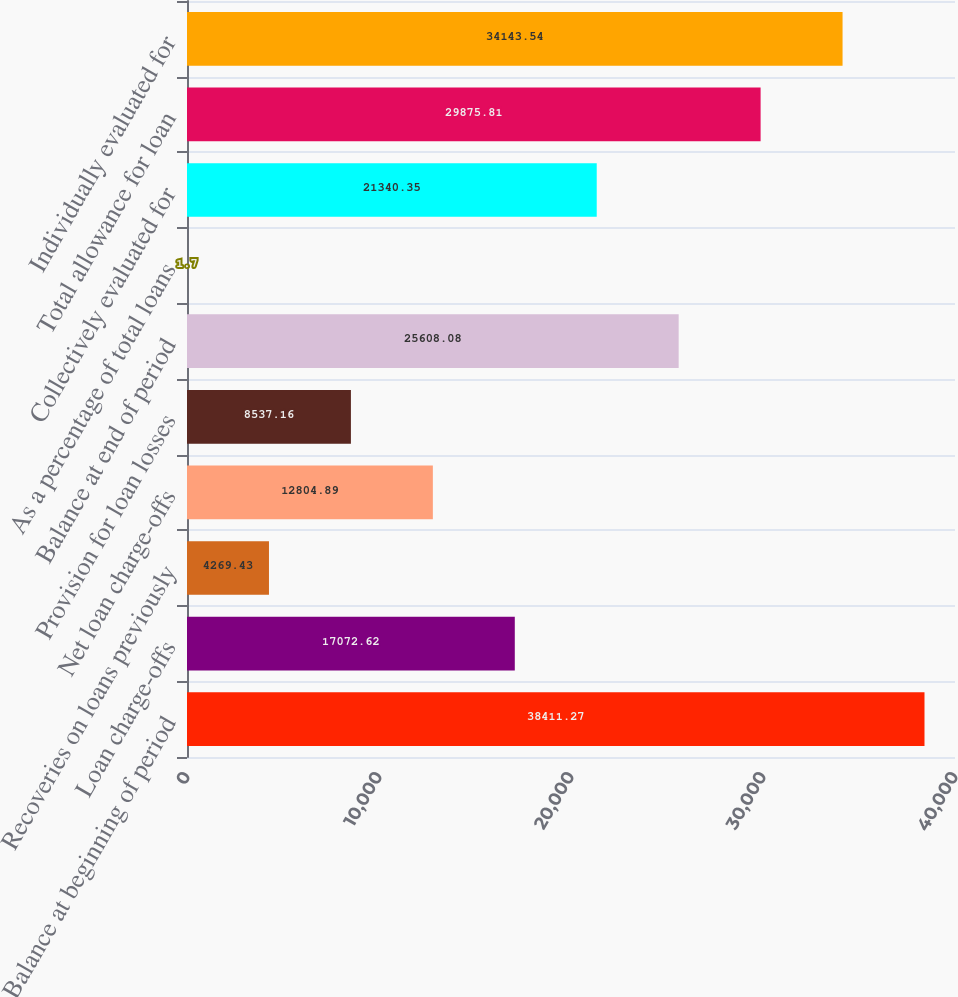<chart> <loc_0><loc_0><loc_500><loc_500><bar_chart><fcel>Balance at beginning of period<fcel>Loan charge-offs<fcel>Recoveries on loans previously<fcel>Net loan charge-offs<fcel>Provision for loan losses<fcel>Balance at end of period<fcel>As a percentage of total loans<fcel>Collectively evaluated for<fcel>Total allowance for loan<fcel>Individually evaluated for<nl><fcel>38411.3<fcel>17072.6<fcel>4269.43<fcel>12804.9<fcel>8537.16<fcel>25608.1<fcel>1.7<fcel>21340.3<fcel>29875.8<fcel>34143.5<nl></chart> 